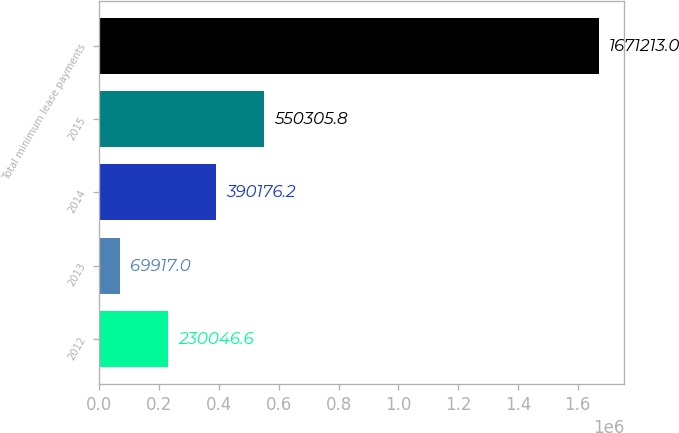Convert chart. <chart><loc_0><loc_0><loc_500><loc_500><bar_chart><fcel>2012<fcel>2013<fcel>2014<fcel>2015<fcel>Total minimum lease payments<nl><fcel>230047<fcel>69917<fcel>390176<fcel>550306<fcel>1.67121e+06<nl></chart> 